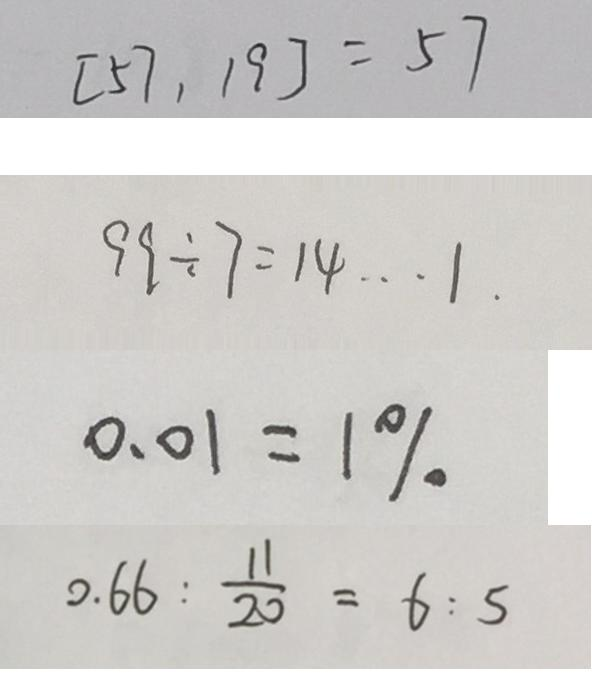Convert formula to latex. <formula><loc_0><loc_0><loc_500><loc_500>[ 5 7 , 1 9 ] = 5 7 
 9 9 \div 7 = 1 4 \cdots 1 \cdot 
 0 . 0 1 = 1 \% 
 0 . 6 6 : \frac { 1 1 } { 2 0 } = 6 : 5</formula> 